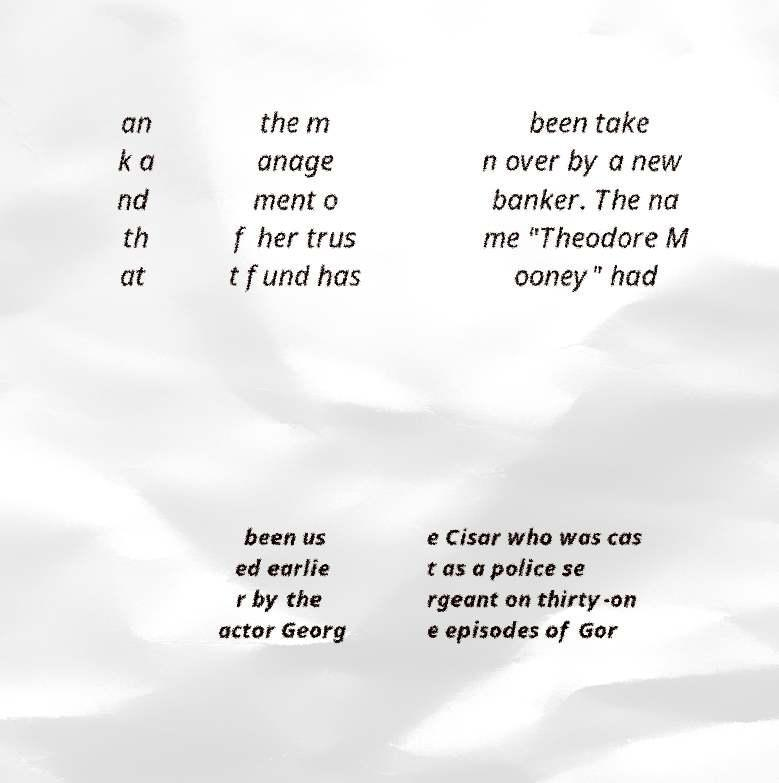For documentation purposes, I need the text within this image transcribed. Could you provide that? an k a nd th at the m anage ment o f her trus t fund has been take n over by a new banker. The na me "Theodore M ooney" had been us ed earlie r by the actor Georg e Cisar who was cas t as a police se rgeant on thirty-on e episodes of Gor 